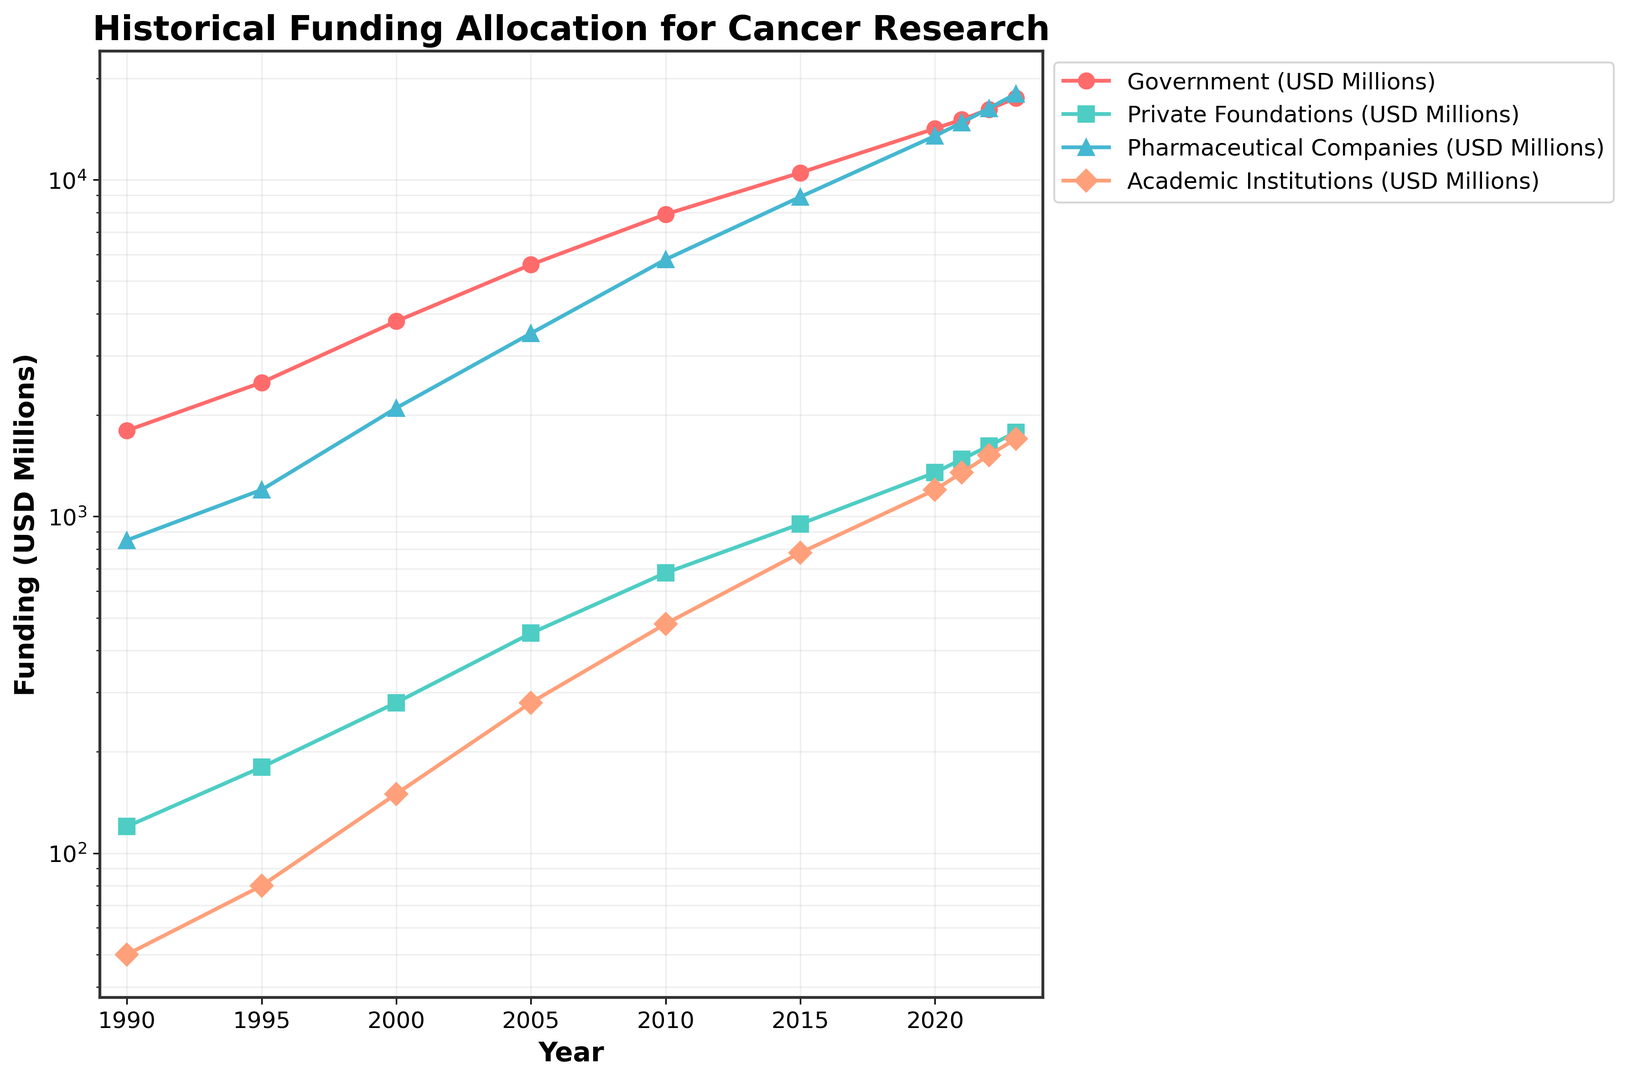What year did government funding surpass 10,000 million USD? The government funding line crosses the 10,000 million USD mark between 2010 and 2015. By looking at the specific data points, we can see that in 2015 it is 10,500 million USD.
Answer: 2015 What is the total funding from private foundations and academic institutions in 2020? By adding the funding amounts for private foundations and academic institutions in 2020: 1350 + 1200 = 2550 million USD.
Answer: 2550 million USD Which funding source saw the highest growth rate between 1990 and 2023? The figures show a significant increase in funding amounts across all sectors. Calculating the growth rate: 
- Government: (17500 - 1800) / 1800 = 872.2%
- Private Foundations: (1780 - 120) / 120 = 1383.3%
- Pharmaceutical Companies: (18000 - 850) / 850 = 2017.6%
- Academic Institutions: (1700 - 50) / 50 = 3300%
The highest growth rate is observed in academic institutions.
Answer: Academic Institutions Which sector had the smallest funding amount in 1995? By comparing funding amounts in 1995: 
- Government: 2500 million USD
- Private Foundations: 180 million USD
- Pharmaceutical Companies: 1200 million USD
- Academic Institutions: 80 million USD
The smallest amount is from academic institutions.
Answer: Academic Institutions What is the average annual funding for pharmaceutical companies from 1990 to 2023? To calculate the average: 
(850 + 1200 + 2100 + 3500 + 5800 + 8900 + 13500 + 14800 + 16300 + 18000) / 10 = 9295 million USD.
Answer: 9295 million USD How does the funding in 2023 of academic institutions compare to government funding in 1990? The funding in 2023 for academic institutions is 1700 million USD, and government funding in 1990 is 1800 million USD. Comparing these amounts:
1700 is less than 1800.
Answer: Less What is the difference in funding between pharmaceutical companies and private foundations in 2015? The funding for pharmaceutical companies in 2015 is 8900 million USD, and for private foundations, it is 950 million USD. The difference:
8900 - 950 = 7950 million USD.
Answer: 7950 million USD Which color represents the least funded sector in 2000? The least funded sector in 2000 is academic institutions with 150 million USD, which is represented by the color associated with academic institutions in the figure, which appears as salmon/orange.
Answer: Salmon/Orange What is the cumulative government funding over the entire period shown? Adding all government funding amounts from 1990 to 2023:
1800 + 2500 + 3800 + 5600 + 7900 + 10500 + 14200 + 15100 + 16200 + 17500 = 95100 million USD.
Answer: 95100 million USD In which year did private foundation funding first exceed 1000 million USD? The private foundation funding first exceed 1000 million USD in the year 2015, where it reached 950 million USD, so it would be the next year, 2020, exceeding 1000 million USD.
Answer: 2020 